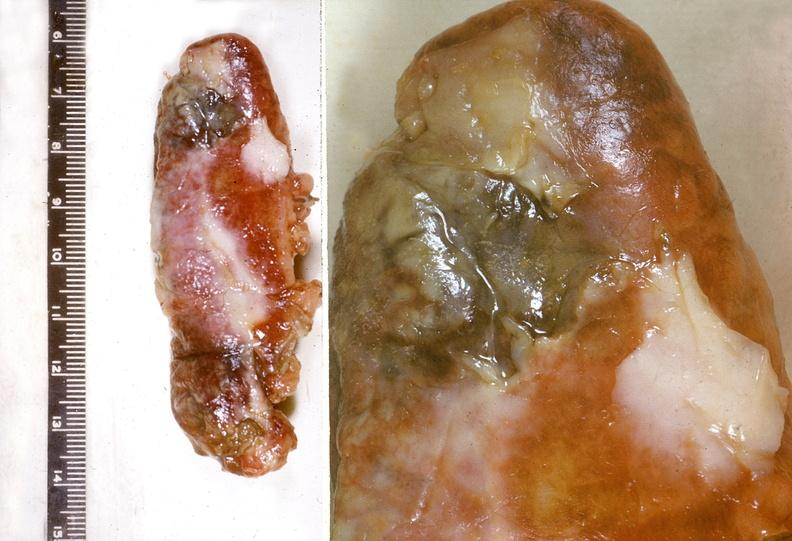does this image show appendix, acute appendicitis with gangreene?
Answer the question using a single word or phrase. Yes 